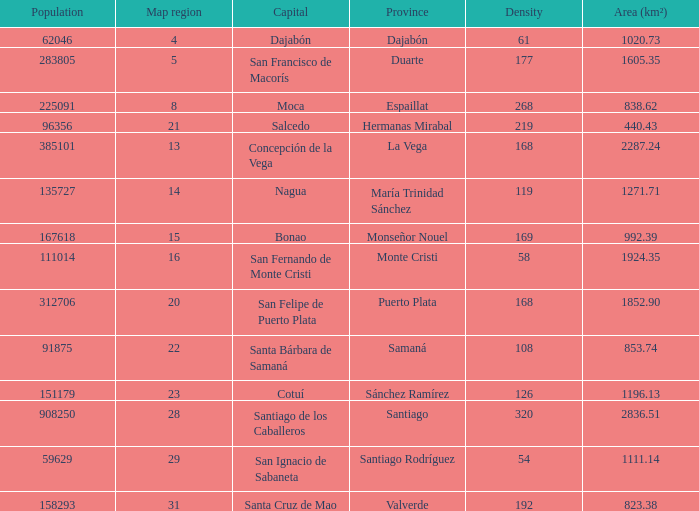When area (km²) is 1605.35, how many provinces are there? 1.0. 